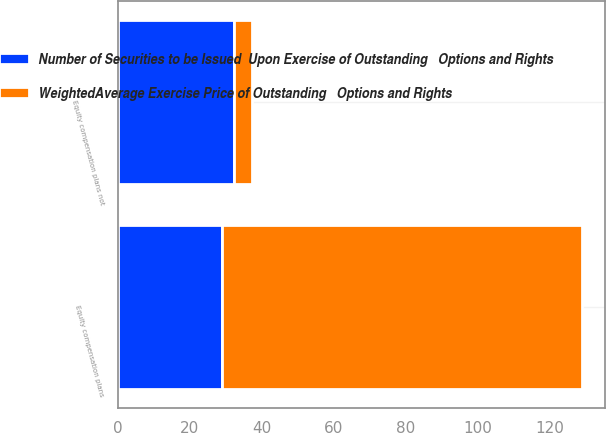Convert chart. <chart><loc_0><loc_0><loc_500><loc_500><stacked_bar_chart><ecel><fcel>Equity compensation plans<fcel>Equity compensation plans not<nl><fcel>WeightedAverage Exercise Price of Outstanding   Options and Rights<fcel>100<fcel>5<nl><fcel>Number of Securities to be Issued  Upon Exercise of Outstanding   Options and Rights<fcel>28.86<fcel>32.14<nl></chart> 